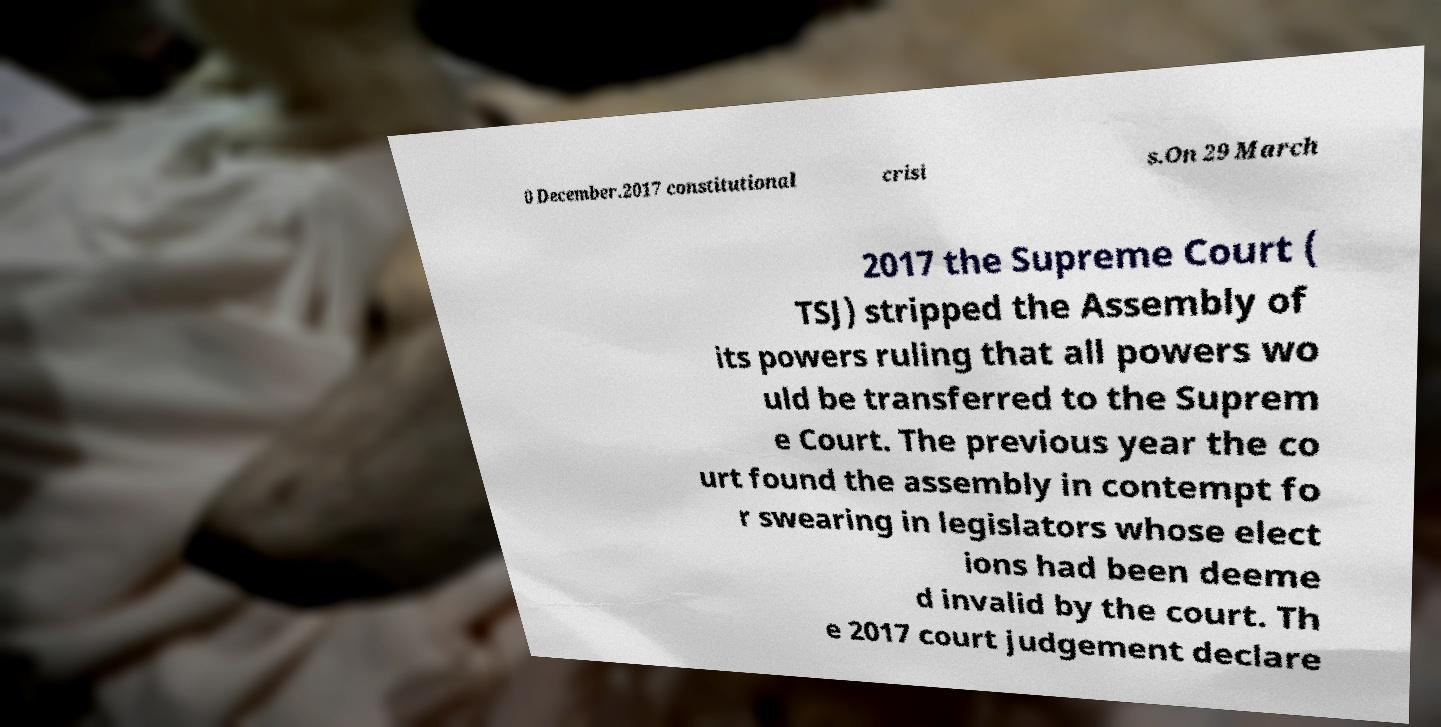Please identify and transcribe the text found in this image. 0 December.2017 constitutional crisi s.On 29 March 2017 the Supreme Court ( TSJ) stripped the Assembly of its powers ruling that all powers wo uld be transferred to the Suprem e Court. The previous year the co urt found the assembly in contempt fo r swearing in legislators whose elect ions had been deeme d invalid by the court. Th e 2017 court judgement declare 